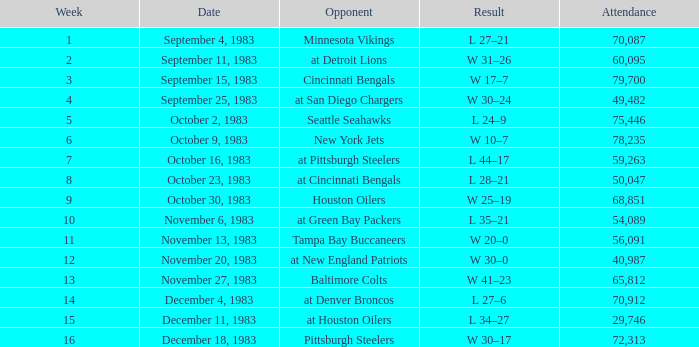What is the mean attendance following week 16? None. 